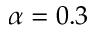<formula> <loc_0><loc_0><loc_500><loc_500>\alpha = 0 . 3</formula> 